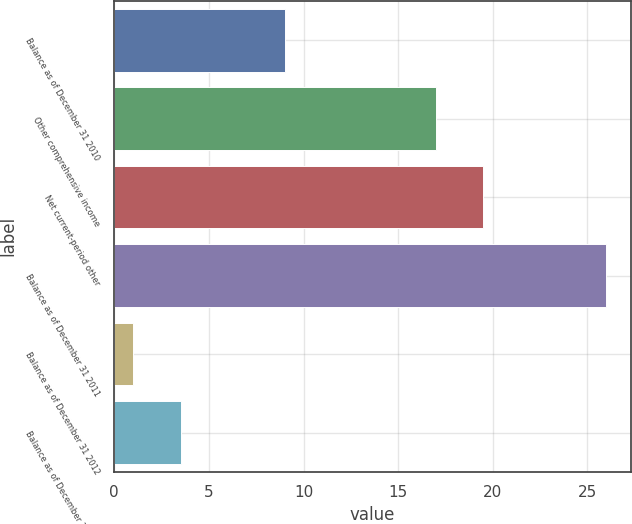Convert chart. <chart><loc_0><loc_0><loc_500><loc_500><bar_chart><fcel>Balance as of December 31 2010<fcel>Other comprehensive income<fcel>Net current-period other<fcel>Balance as of December 31 2011<fcel>Balance as of December 31 2012<fcel>Balance as of December 31 2013<nl><fcel>9<fcel>17<fcel>19.5<fcel>26<fcel>1<fcel>3.5<nl></chart> 